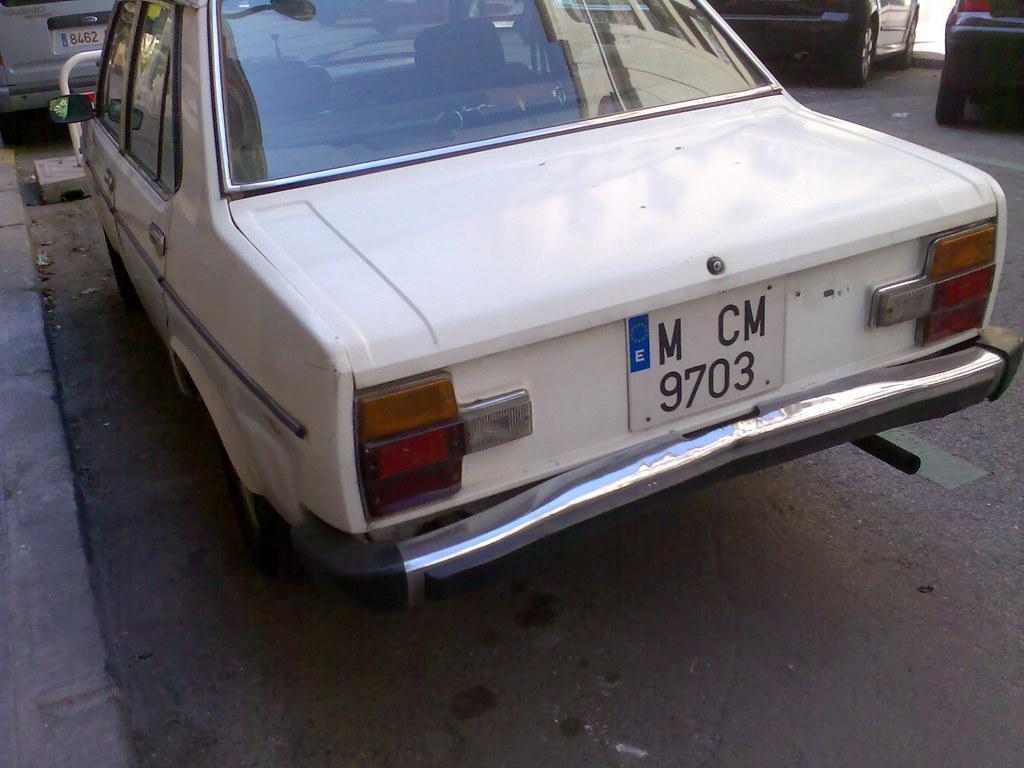What type of vehicle is in the image? There is a white car in the image. What can be seen on the car? The car has a number plate. Where is the car located? The car is parked on the road. What else can be seen in the image? Vehicles and a rod are visible at the top of the image. What type of punishment is being given to the car in the image? There is no punishment being given to the car in the image; it is simply parked on the road. How many dogs are visible in the image? There are no dogs present in the image. 